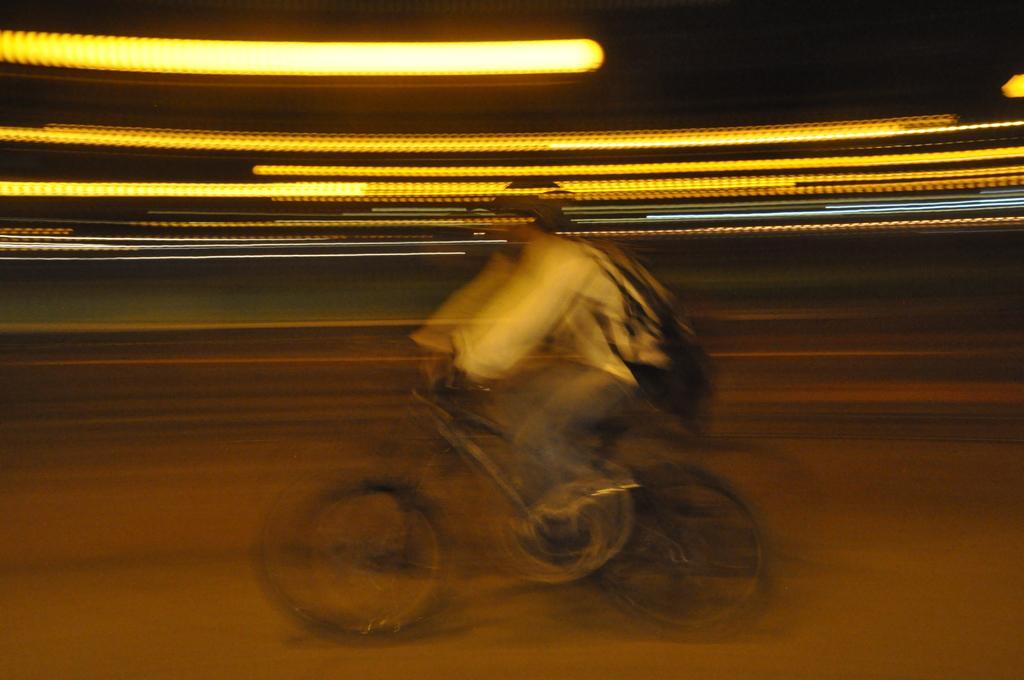Please provide a concise description of this image. In this picture there is a boy in the center of the image, on a bicycle. 